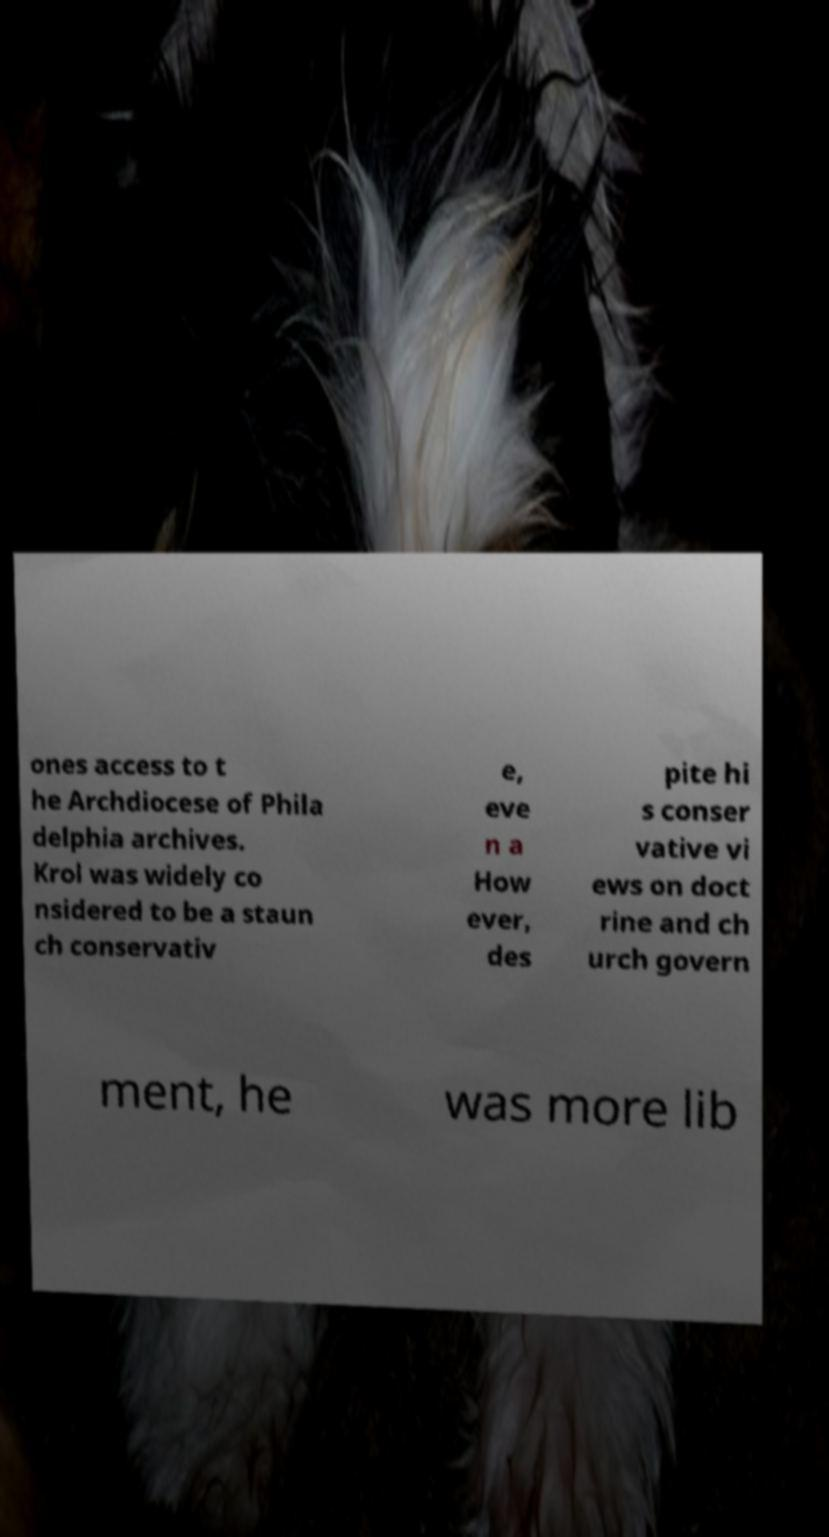Please identify and transcribe the text found in this image. ones access to t he Archdiocese of Phila delphia archives. Krol was widely co nsidered to be a staun ch conservativ e, eve n a How ever, des pite hi s conser vative vi ews on doct rine and ch urch govern ment, he was more lib 